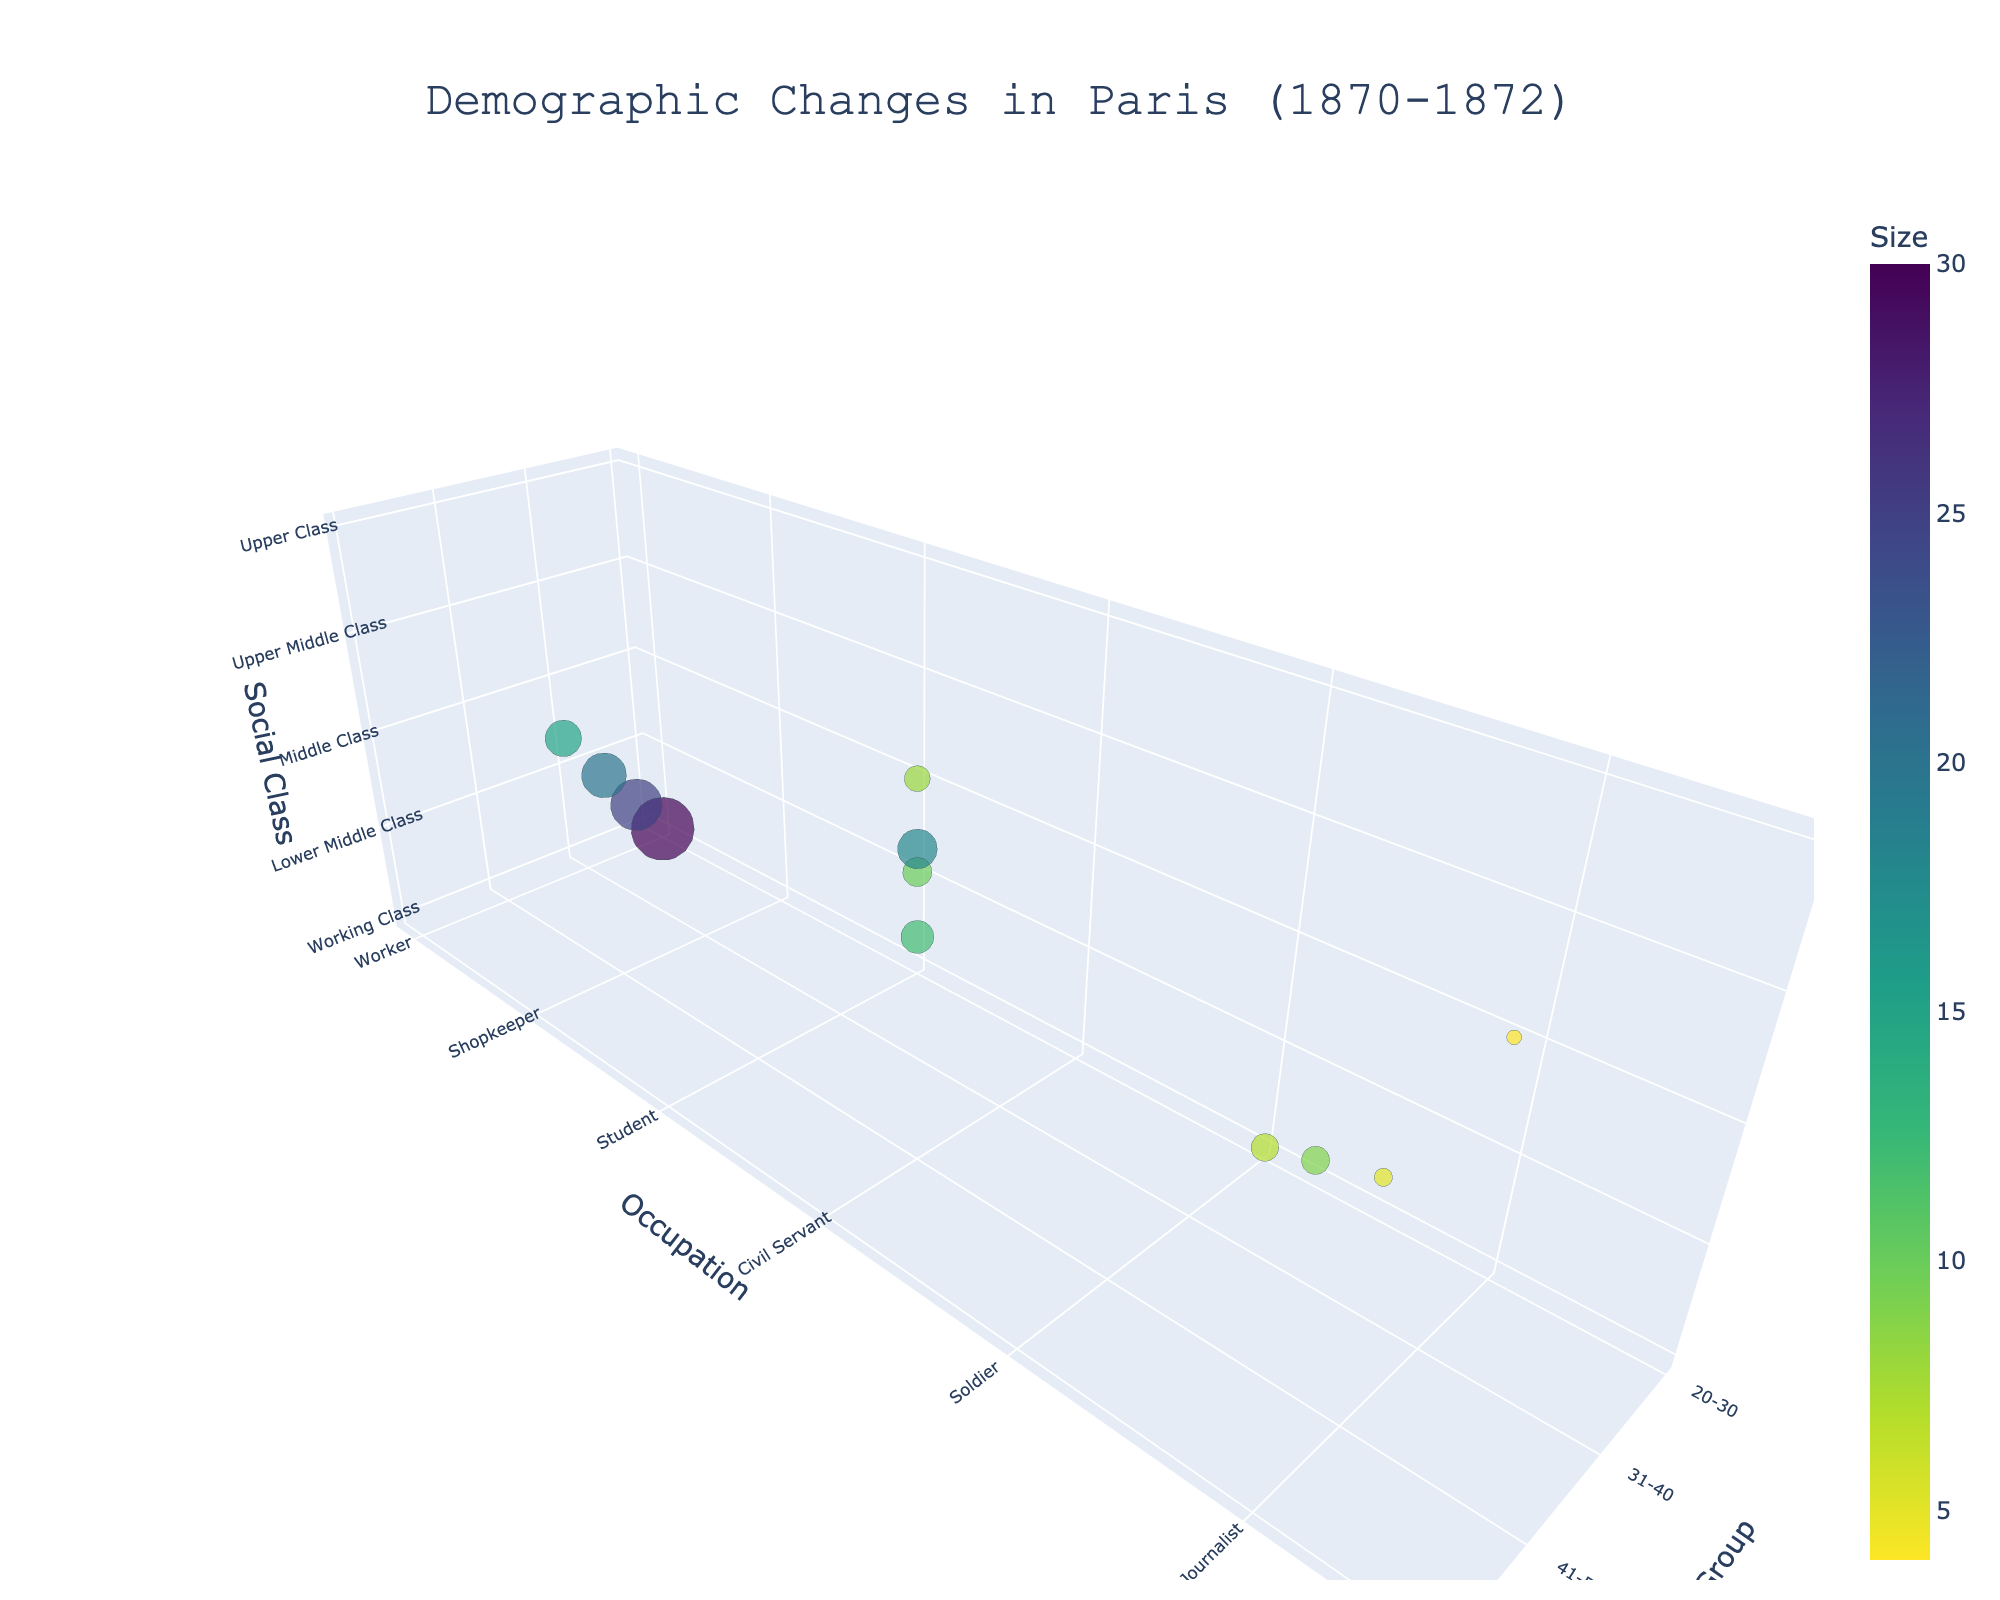What is the title of the figure? The title is usually placed at the top of the figure in a larger font size for better visibility. The figure's title is "Demographic Changes in Paris (1870-1872)."
Answer: Demographic Changes in Paris (1870-1872) Which age group and occupation has the largest bubble size? To find the largest bubble size, identify and compare the size of all bubbles, which represents the average population. The 20-30 age group and Workers have the largest bubble size.
Answer: 20-30, Workers Which social class had the smallest population in 1871? Locate the smallest bubble size at the "Population1871" level. Upper Class, represented by Rentier and Factory Owner, had the smallest population in 1871.
Answer: Upper Class (Rentier, Factory Owner) How did the population of workers aged 20-30 change from 1870 to 1872? Observe the bubbles corresponding to 20-30 aged Workers for years 1870, 1871, and 1872. The population decreased from 180,000 in 1870 to 150,000 in 1871, and then increased to 165,000 in 1872.
Answer: Decreased then increased Compare the bubble sizes of Shopkeepers aged 41-50 and Journalists aged 41-50. Which one is larger? Inspect the sizes of the bubbles for Shopkeepers and Journalists in the 41-50 age group. The bubble for Shopkeepers is larger.
Answer: Shopkeepers (41-50) What is the overall trend in population for the Middle Class across all age groups from 1870 to 1872? Compare the bubble sizes representing the Middle Class for all age groups from 1870 to 1872. The population generally decreased from 1870 to 1871, then increased slightly in 1872.
Answer: Decrease then slight increase Which group experienced the greatest increase in population from 1871 to 1872? Find the group with the most significant increase in bubble size from 1871 to 1872. The 20-30 age group of soldiers saw the most significant increase from 40,000 to 30,000.
Answer: Soldiers (20-30) Among Teachers aged 31-40 and Professionals aged 51-60, who had a higher population in 1871? Examine the bubble sizes for Teachers aged 31-40 and Professionals aged 51-60 for the year 1871. Teachers had a higher population in 1871.
Answer: Teachers (31-40) Calculate the average population of Merchants aged 31-40 across the 3 years. Compute the average by summing up the populations for 1870, 1871, and 1872, then dividing by three. (70000 + 60000 + 65000) / 3 = 65000
Answer: 65000 How does the population of Lower Middle Class change by occupation from 1870 to 1872? Assess the bubble sizes for the Lower Middle Class across different occupations for each year. The population typically decreases from 1870 to 1871 and then slightly increases or remains stable in 1872.
Answer: Decrease then slight increase/stable 